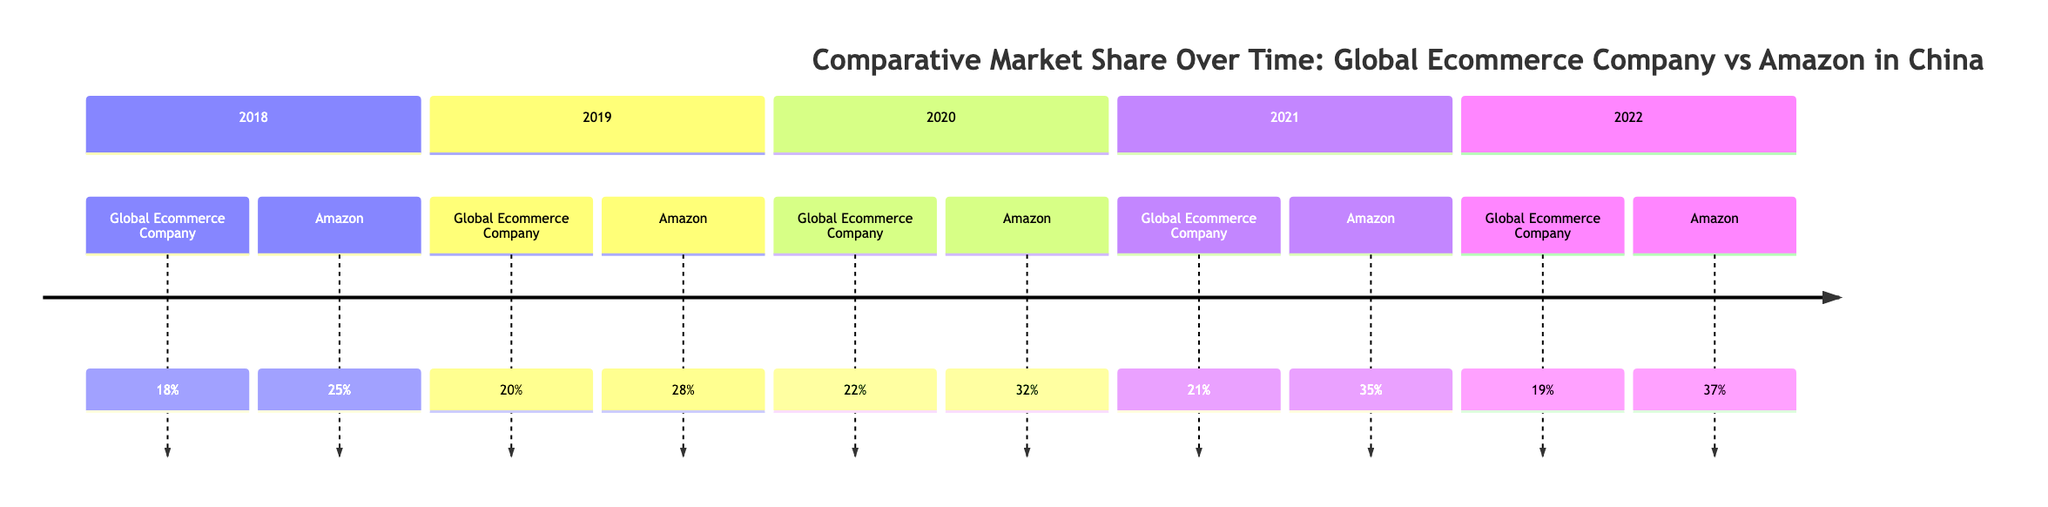What was the market share of the Global Ecommerce Company in 2020? The diagram shows the market share of the Global Ecommerce Company in 2020 as 22%.
Answer: 22% What was Amazon's market share in 2021? According to the diagram, Amazon's market share in 2021 was 35%.
Answer: 35% Which year saw the highest market share for Amazon? By reviewing the values for Amazon over the years, 2022 shows the highest market share at 37%.
Answer: 37% How many times did the Global Ecommerce Company's market share decline from 2018 to 2022? The Global Ecommerce Company experienced a decline in market share in 2021 (from 22% to 21%) and a further decline in 2022 (from 21% to 19%), totaling two declines.
Answer: 2 What was the market share difference between Global Ecommerce Company and Amazon in 2019? In 2019, the Global Ecommerce Company had a market share of 20%, while Amazon had 28%, resulting in a difference of 8%.
Answer: 8% In which year did the Global Ecommerce Company last see an increase in market share? By examining the years, 2020 is the last year the Global Ecommerce Company saw an increase, moving from 20% in 2019 to 22%.
Answer: 2020 What trend is observed in Amazon's market share from 2018 to 2022? The diagram indicates a consistent upward trend in Amazon's market share, increasing from 25% in 2018 to 37% in 2022.
Answer: Upward Which company's market share was consistently lower from 2018 to 2022? The Global Ecommerce Company's market share was consistently lower than Amazon's throughout the years provided.
Answer: Global Ecommerce Company How much did the Global Ecommerce Company's market share decrease from 2020 to 2022? The market share of the Global Ecommerce Company decreased from 22% in 2020 to 19% in 2022, which is a decrease of 3%.
Answer: 3% 